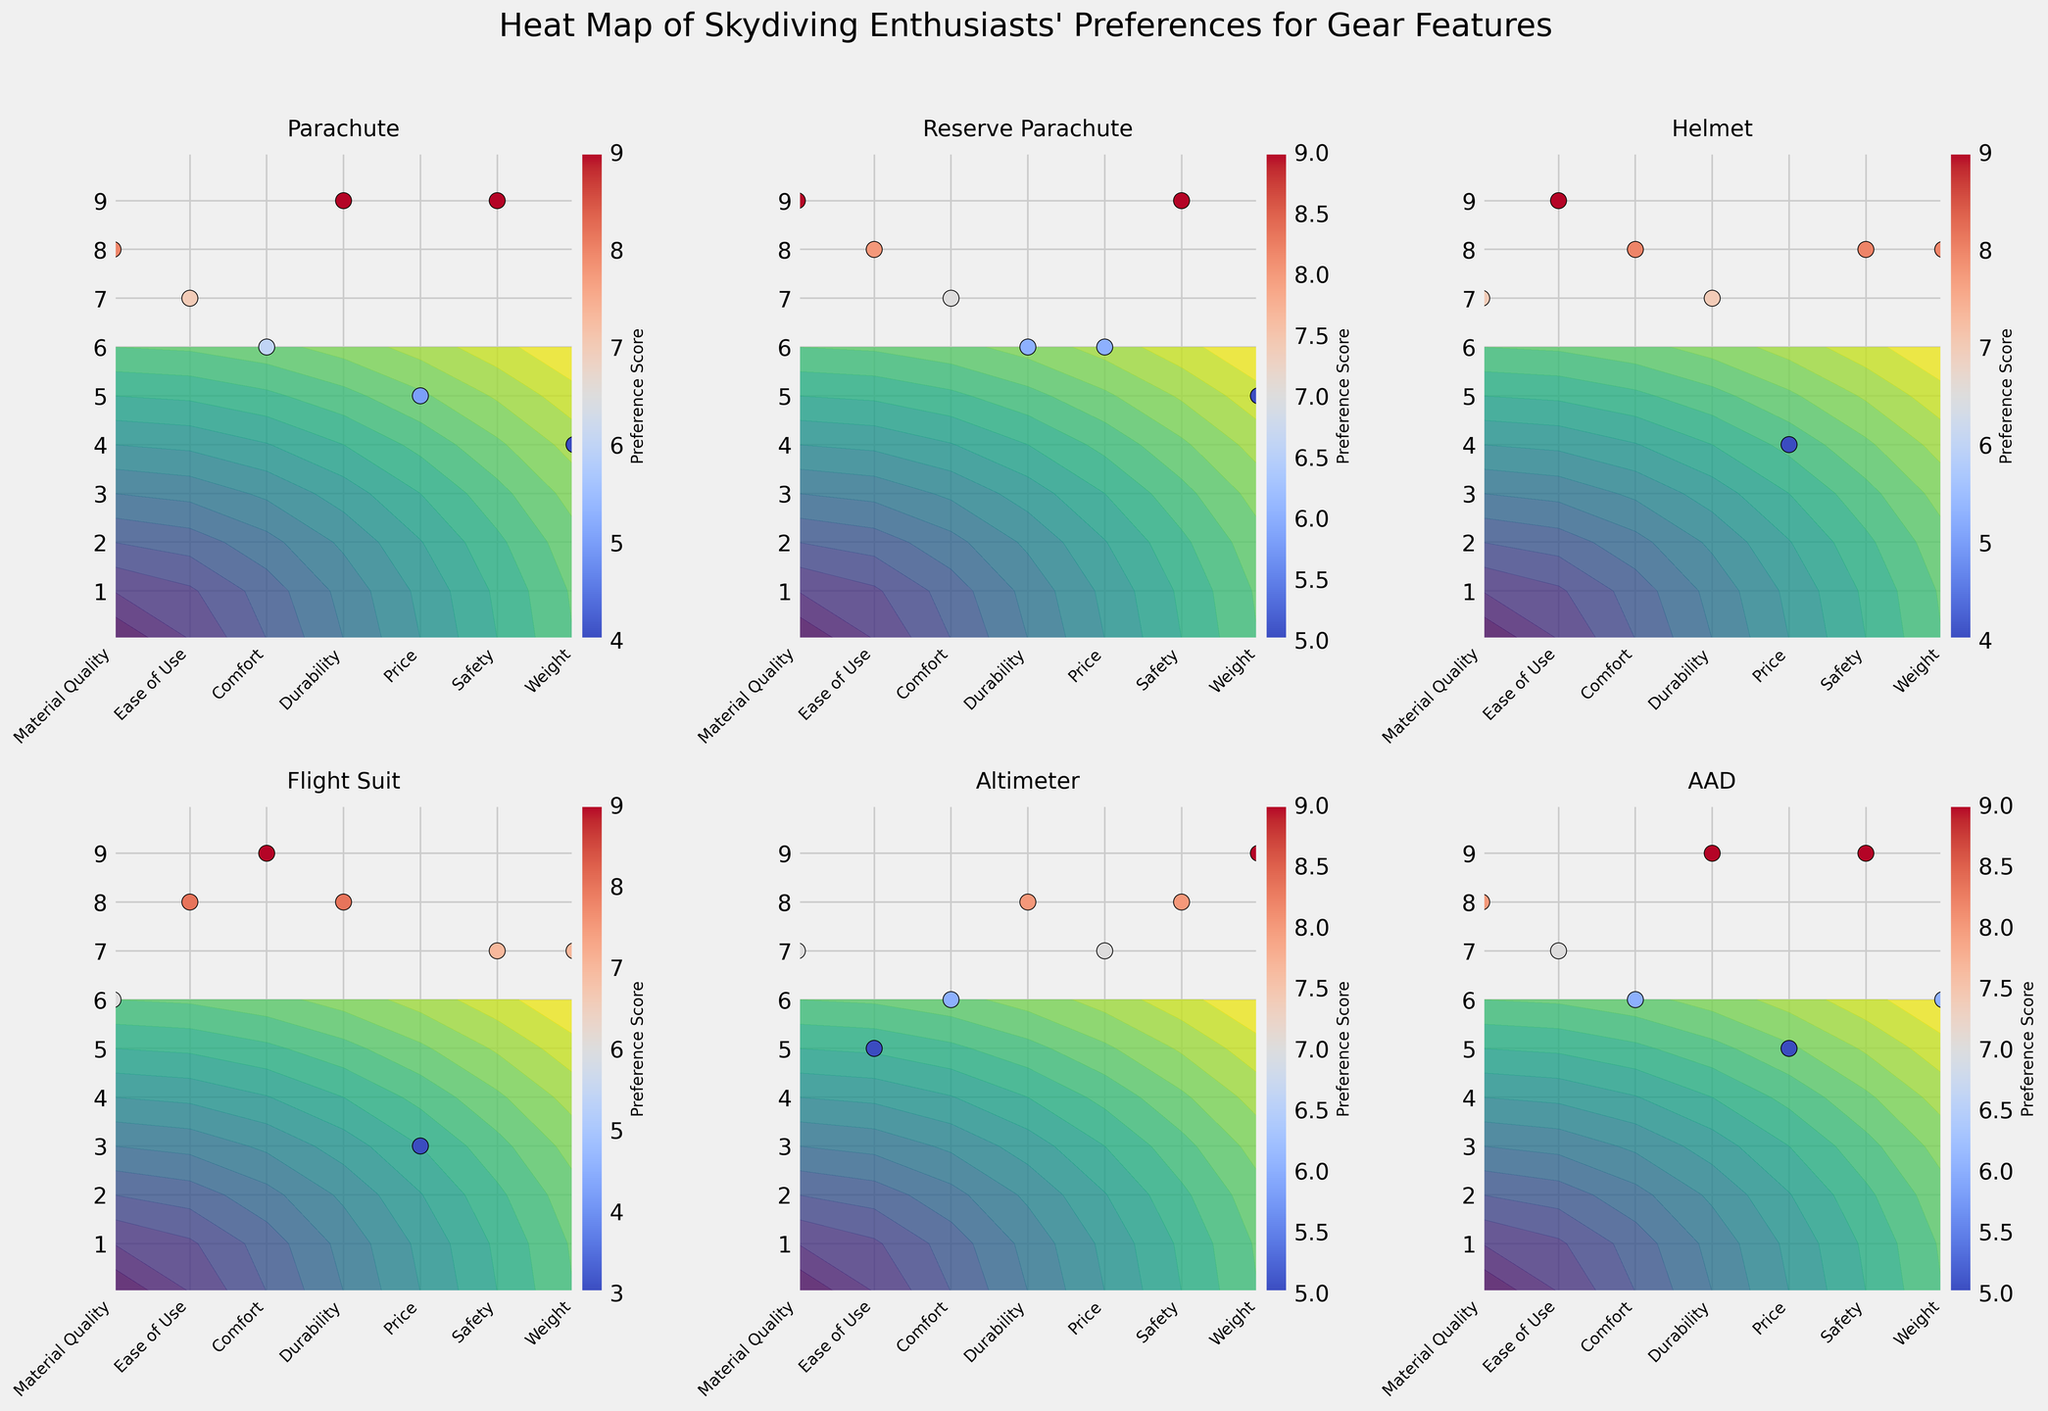What is the title of the figure? The title of the figure is usually located at the top center of the plot. Observing the top part of the figure, you'll see the main title that summarizes the overall context of the plot.
Answer: "Heat Map of Skydiving Enthusiasts' Preferences for Gear Features" Which gear type has the highest preference score for Comfort? To determine this, look at the Comfort row and identify the highest preference score. Next, match this score to the corresponding gear type column.
Answer: Helmet What is the median preference score for the Parachute across all features? List the preference scores for the Parachute: 8, 7, 6, 9, 5, 9, 4. Arrange these values in ascending order: 4, 5, 6, 7, 8, 9, 9. The median is the middle value, which is 7.
Answer: 7 Which features have a higher preference score for the Altimeter than for the Flight Suit? Compare the scores for each feature for the Altimeter and Flight Suit: Material Quality (7 vs. 6), Ease of Use (5 vs. 8), Comfort (6 vs. 9), Durability (8 vs. 8), Price (7 vs. 3), Safety (8 vs. 7), Weight (9 vs. 7). The features with higher scores for Altimeter are Material Quality, Durability, Price, Safety, and Weight.
Answer: Material Quality, Price, Safety, Weight What is the average preference score for the Reserve Parachute? Sum the scores for the Reserve Parachute: 9 + 8 + 7 + 6 + 6 + 9 + 5 = 50. Then divide by the number of features (7): 50 / 7 ≈ 7.14.
Answer: 7.14 Which gear type has the most consistent (least variable) preference scores across all features? Calculate the range (difference between highest and lowest scores) for each gear type and identify the smallest range. Parachute: 9-4=5, Reserve Parachute: 9-5=4, Helmet: 9-4=5, Flight Suit: 9-3=6, Altimeter: 9-5=4, AAD: 9-6=3. AAD has the range of 3 which is the smallest.
Answer: AAD Which gear type has the least importance placed on Price based on preference scores? Identify the lowest score in the Price row and find the corresponding gear type: Prices are Parachute (5), Reserve Parachute (6), Helmet (4), Flight Suit (3), Altimeter (7), AAD (5). The lowest is 3 for the Flight Suit.
Answer: Flight Suit What is the total sum of preference scores for the AAD across all features? Sum the preference scores for AAD: 8 (Material Quality) + 7 (Ease of Use) + 6 (Comfort) + 9 (Durability) + 5 (Price) + 9 (Safety) + 6 (Weight). 8 + 7 + 6 + 9 + 5 + 9 + 6 = 50.
Answer: 50 Which feature generally scores highest across all gear types? For each feature, determine the highest score and compare them. Material Quality (9), Ease of Use (9), Comfort (9), Durability (9), Price (7), Safety (9), Weight (9). The features with the highest score of 9 are Material Quality, Ease of Use, Comfort, Durability, Safety, and Weight.
Answer: Material Quality, Ease of Use, Comfort, Durability, Safety, Weight 